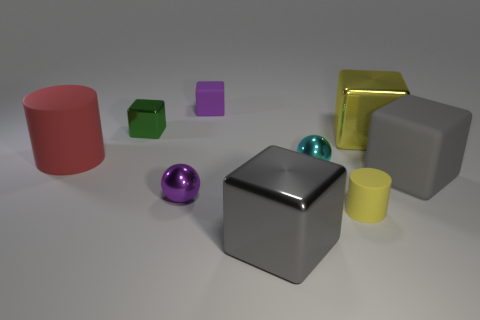Subtract all green cubes. How many cubes are left? 4 Subtract all yellow cubes. How many cubes are left? 4 Subtract all red cubes. Subtract all red cylinders. How many cubes are left? 5 Subtract all balls. How many objects are left? 7 Add 8 small purple balls. How many small purple balls are left? 9 Add 1 tiny purple objects. How many tiny purple objects exist? 3 Subtract 0 cyan blocks. How many objects are left? 9 Subtract all big shiny cylinders. Subtract all gray blocks. How many objects are left? 7 